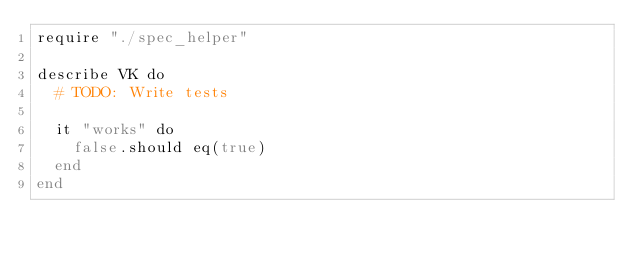Convert code to text. <code><loc_0><loc_0><loc_500><loc_500><_Crystal_>require "./spec_helper"

describe VK do
  # TODO: Write tests

  it "works" do
    false.should eq(true)
  end
end
</code> 